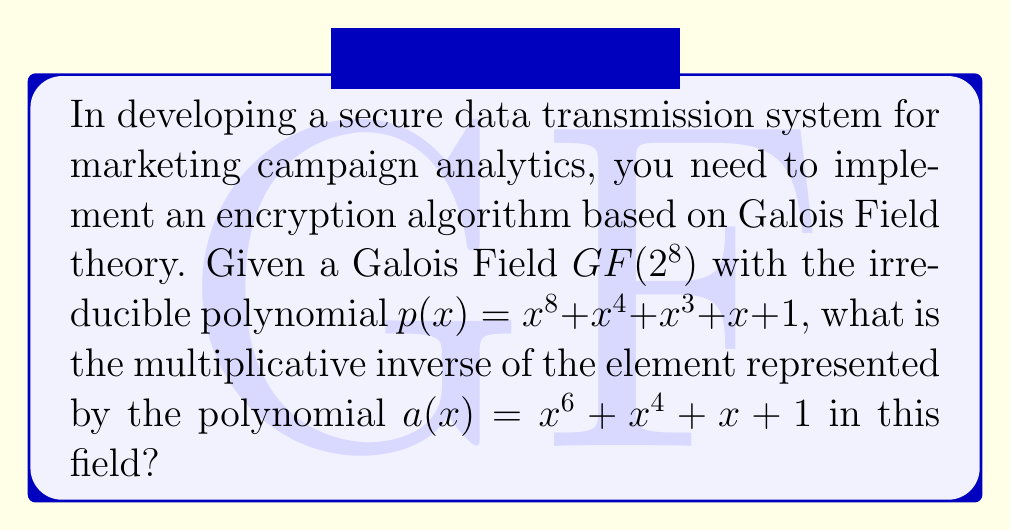Provide a solution to this math problem. To find the multiplicative inverse of $a(x)$ in $GF(2^8)$, we can use the Extended Euclidean Algorithm:

1) First, let's set up the initial conditions:
   $r_0(x) = p(x) = x^8 + x^4 + x^3 + x + 1$
   $r_1(x) = a(x) = x^6 + x^4 + x + 1$
   $s_0(x) = 1$, $s_1(x) = 0$
   $t_0(x) = 0$, $t_1(x) = 1$

2) We perform polynomial long division and keep track of quotients and remainders:

   $x^8 + x^4 + x^3 + x + 1 = (x^2 + x + 1)(x^6 + x^4 + x + 1) + (x^5 + x^2)$
   
   $q_1(x) = x^2 + x + 1$
   $r_2(x) = x^5 + x^2$

3) We continue this process:

   $x^6 + x^4 + x + 1 = (x + 1)(x^5 + x^2) + (x^4 + x^3 + x^2 + 1)$
   
   $q_2(x) = x + 1$
   $r_3(x) = x^4 + x^3 + x^2 + 1$

   $x^5 + x^2 = (x)(x^4 + x^3 + x^2 + 1) + (x^3 + x^2 + x)$
   
   $q_3(x) = x$
   $r_4(x) = x^3 + x^2 + x$

   $x^4 + x^3 + x^2 + 1 = (x + 1)(x^3 + x^2 + x) + 1$
   
   $q_4(x) = x + 1$
   $r_5(x) = 1$

4) The process stops here as we've reached a remainder of 1. Now we work backwards to find $s_i(x)$ and $t_i(x)$:

   $s_2(x) = s_0(x) - q_1(x)s_1(x) = 1 - (x^2 + x + 1)(0) = 1$
   $t_2(x) = t_0(x) - q_1(x)t_1(x) = 0 - (x^2 + x + 1)(1) = x^2 + x + 1$

   $s_3(x) = s_1(x) - q_2(x)s_2(x) = 0 - (x + 1)(1) = x + 1$
   $t_3(x) = t_1(x) - q_2(x)t_2(x) = 1 - (x + 1)(x^2 + x + 1) = x^3 + x^2$

   $s_4(x) = s_2(x) - q_3(x)s_3(x) = 1 - x(x + 1) = x^2 + x + 1$
   $t_4(x) = t_2(x) - q_3(x)t_3(x) = (x^2 + x + 1) - x(x^3 + x^2) = x^4 + x^2 + x + 1$

   $s_5(x) = s_3(x) - q_4(x)s_4(x) = (x + 1) - (x + 1)(x^2 + x + 1) = x^3 + x^2$
   $t_5(x) = t_3(x) - q_4(x)t_4(x) = (x^3 + x^2) - (x + 1)(x^4 + x^2 + x + 1) = x^5 + x^4 + x^2 + x$

5) The multiplicative inverse of $a(x)$ is $t_5(x) = x^5 + x^4 + x^2 + x$ in $GF(2^8)$.

You can verify this by multiplying $a(x)$ and $t_5(x)$ modulo $p(x)$, which should result in 1.
Answer: $x^5 + x^4 + x^2 + x$ 